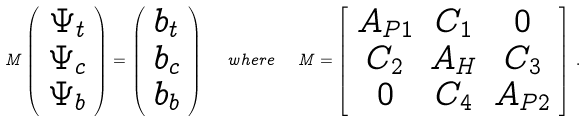Convert formula to latex. <formula><loc_0><loc_0><loc_500><loc_500>M \left ( \begin{array} { c } \Psi _ { t } \\ \Psi _ { c } \\ \Psi _ { b } \end{array} \right ) = \left ( \begin{array} { c } b _ { t } \\ b _ { c } \\ b _ { b } \end{array} \right ) \ \ w h e r e \ \ M = \left [ \begin{array} { c c c } A _ { P 1 } & C _ { 1 } & 0 \\ C _ { 2 } & A _ { H } & C _ { 3 } \\ 0 & C _ { 4 } & A _ { P 2 } \end{array} \right ] \, .</formula> 